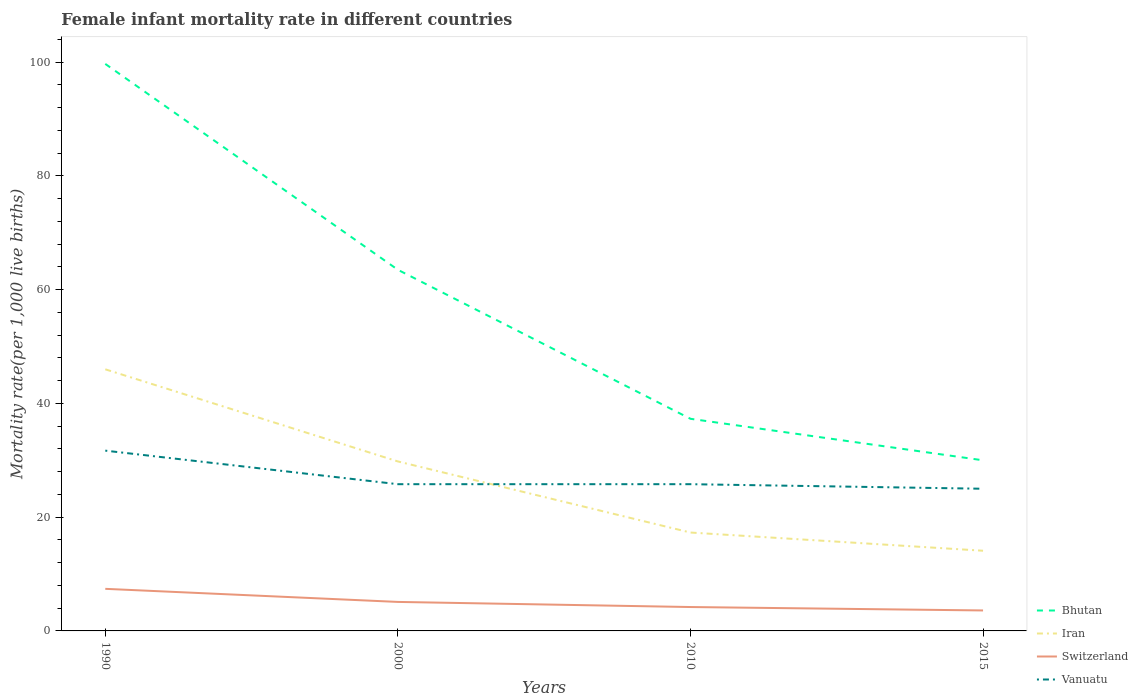In which year was the female infant mortality rate in Bhutan maximum?
Provide a succinct answer. 2015. What is the total female infant mortality rate in Bhutan in the graph?
Keep it short and to the point. 7.3. What is the difference between the highest and the second highest female infant mortality rate in Switzerland?
Provide a short and direct response. 3.8. How many lines are there?
Make the answer very short. 4. How many years are there in the graph?
Offer a terse response. 4. What is the difference between two consecutive major ticks on the Y-axis?
Make the answer very short. 20. Are the values on the major ticks of Y-axis written in scientific E-notation?
Keep it short and to the point. No. Does the graph contain any zero values?
Your response must be concise. No. Does the graph contain grids?
Your answer should be very brief. No. Where does the legend appear in the graph?
Make the answer very short. Bottom right. How many legend labels are there?
Your response must be concise. 4. What is the title of the graph?
Ensure brevity in your answer.  Female infant mortality rate in different countries. Does "Argentina" appear as one of the legend labels in the graph?
Make the answer very short. No. What is the label or title of the Y-axis?
Provide a succinct answer. Mortality rate(per 1,0 live births). What is the Mortality rate(per 1,000 live births) in Bhutan in 1990?
Keep it short and to the point. 99.7. What is the Mortality rate(per 1,000 live births) of Iran in 1990?
Provide a succinct answer. 46. What is the Mortality rate(per 1,000 live births) in Switzerland in 1990?
Provide a short and direct response. 7.4. What is the Mortality rate(per 1,000 live births) in Vanuatu in 1990?
Make the answer very short. 31.7. What is the Mortality rate(per 1,000 live births) in Bhutan in 2000?
Your response must be concise. 63.5. What is the Mortality rate(per 1,000 live births) of Iran in 2000?
Offer a very short reply. 29.8. What is the Mortality rate(per 1,000 live births) in Switzerland in 2000?
Your answer should be very brief. 5.1. What is the Mortality rate(per 1,000 live births) in Vanuatu in 2000?
Provide a succinct answer. 25.8. What is the Mortality rate(per 1,000 live births) in Bhutan in 2010?
Your answer should be very brief. 37.3. What is the Mortality rate(per 1,000 live births) in Iran in 2010?
Your answer should be very brief. 17.3. What is the Mortality rate(per 1,000 live births) of Switzerland in 2010?
Make the answer very short. 4.2. What is the Mortality rate(per 1,000 live births) in Vanuatu in 2010?
Provide a succinct answer. 25.8. What is the Mortality rate(per 1,000 live births) in Iran in 2015?
Offer a very short reply. 14.1. What is the Mortality rate(per 1,000 live births) in Vanuatu in 2015?
Keep it short and to the point. 25. Across all years, what is the maximum Mortality rate(per 1,000 live births) of Bhutan?
Ensure brevity in your answer.  99.7. Across all years, what is the maximum Mortality rate(per 1,000 live births) in Vanuatu?
Your answer should be very brief. 31.7. Across all years, what is the minimum Mortality rate(per 1,000 live births) in Iran?
Your answer should be compact. 14.1. Across all years, what is the minimum Mortality rate(per 1,000 live births) of Switzerland?
Your answer should be compact. 3.6. Across all years, what is the minimum Mortality rate(per 1,000 live births) of Vanuatu?
Provide a succinct answer. 25. What is the total Mortality rate(per 1,000 live births) in Bhutan in the graph?
Your answer should be compact. 230.5. What is the total Mortality rate(per 1,000 live births) in Iran in the graph?
Provide a succinct answer. 107.2. What is the total Mortality rate(per 1,000 live births) in Switzerland in the graph?
Give a very brief answer. 20.3. What is the total Mortality rate(per 1,000 live births) of Vanuatu in the graph?
Your answer should be very brief. 108.3. What is the difference between the Mortality rate(per 1,000 live births) of Bhutan in 1990 and that in 2000?
Your answer should be compact. 36.2. What is the difference between the Mortality rate(per 1,000 live births) of Iran in 1990 and that in 2000?
Your answer should be compact. 16.2. What is the difference between the Mortality rate(per 1,000 live births) in Switzerland in 1990 and that in 2000?
Make the answer very short. 2.3. What is the difference between the Mortality rate(per 1,000 live births) of Vanuatu in 1990 and that in 2000?
Offer a terse response. 5.9. What is the difference between the Mortality rate(per 1,000 live births) of Bhutan in 1990 and that in 2010?
Your response must be concise. 62.4. What is the difference between the Mortality rate(per 1,000 live births) in Iran in 1990 and that in 2010?
Offer a terse response. 28.7. What is the difference between the Mortality rate(per 1,000 live births) in Vanuatu in 1990 and that in 2010?
Your answer should be compact. 5.9. What is the difference between the Mortality rate(per 1,000 live births) in Bhutan in 1990 and that in 2015?
Offer a very short reply. 69.7. What is the difference between the Mortality rate(per 1,000 live births) in Iran in 1990 and that in 2015?
Give a very brief answer. 31.9. What is the difference between the Mortality rate(per 1,000 live births) of Switzerland in 1990 and that in 2015?
Provide a succinct answer. 3.8. What is the difference between the Mortality rate(per 1,000 live births) in Bhutan in 2000 and that in 2010?
Ensure brevity in your answer.  26.2. What is the difference between the Mortality rate(per 1,000 live births) in Switzerland in 2000 and that in 2010?
Offer a very short reply. 0.9. What is the difference between the Mortality rate(per 1,000 live births) of Bhutan in 2000 and that in 2015?
Offer a terse response. 33.5. What is the difference between the Mortality rate(per 1,000 live births) of Vanuatu in 2000 and that in 2015?
Your answer should be very brief. 0.8. What is the difference between the Mortality rate(per 1,000 live births) of Bhutan in 1990 and the Mortality rate(per 1,000 live births) of Iran in 2000?
Keep it short and to the point. 69.9. What is the difference between the Mortality rate(per 1,000 live births) of Bhutan in 1990 and the Mortality rate(per 1,000 live births) of Switzerland in 2000?
Offer a very short reply. 94.6. What is the difference between the Mortality rate(per 1,000 live births) of Bhutan in 1990 and the Mortality rate(per 1,000 live births) of Vanuatu in 2000?
Keep it short and to the point. 73.9. What is the difference between the Mortality rate(per 1,000 live births) in Iran in 1990 and the Mortality rate(per 1,000 live births) in Switzerland in 2000?
Make the answer very short. 40.9. What is the difference between the Mortality rate(per 1,000 live births) in Iran in 1990 and the Mortality rate(per 1,000 live births) in Vanuatu in 2000?
Provide a short and direct response. 20.2. What is the difference between the Mortality rate(per 1,000 live births) of Switzerland in 1990 and the Mortality rate(per 1,000 live births) of Vanuatu in 2000?
Provide a short and direct response. -18.4. What is the difference between the Mortality rate(per 1,000 live births) of Bhutan in 1990 and the Mortality rate(per 1,000 live births) of Iran in 2010?
Offer a terse response. 82.4. What is the difference between the Mortality rate(per 1,000 live births) in Bhutan in 1990 and the Mortality rate(per 1,000 live births) in Switzerland in 2010?
Keep it short and to the point. 95.5. What is the difference between the Mortality rate(per 1,000 live births) in Bhutan in 1990 and the Mortality rate(per 1,000 live births) in Vanuatu in 2010?
Your response must be concise. 73.9. What is the difference between the Mortality rate(per 1,000 live births) of Iran in 1990 and the Mortality rate(per 1,000 live births) of Switzerland in 2010?
Your response must be concise. 41.8. What is the difference between the Mortality rate(per 1,000 live births) of Iran in 1990 and the Mortality rate(per 1,000 live births) of Vanuatu in 2010?
Offer a terse response. 20.2. What is the difference between the Mortality rate(per 1,000 live births) of Switzerland in 1990 and the Mortality rate(per 1,000 live births) of Vanuatu in 2010?
Make the answer very short. -18.4. What is the difference between the Mortality rate(per 1,000 live births) in Bhutan in 1990 and the Mortality rate(per 1,000 live births) in Iran in 2015?
Your answer should be compact. 85.6. What is the difference between the Mortality rate(per 1,000 live births) of Bhutan in 1990 and the Mortality rate(per 1,000 live births) of Switzerland in 2015?
Provide a succinct answer. 96.1. What is the difference between the Mortality rate(per 1,000 live births) in Bhutan in 1990 and the Mortality rate(per 1,000 live births) in Vanuatu in 2015?
Offer a terse response. 74.7. What is the difference between the Mortality rate(per 1,000 live births) in Iran in 1990 and the Mortality rate(per 1,000 live births) in Switzerland in 2015?
Provide a short and direct response. 42.4. What is the difference between the Mortality rate(per 1,000 live births) in Iran in 1990 and the Mortality rate(per 1,000 live births) in Vanuatu in 2015?
Make the answer very short. 21. What is the difference between the Mortality rate(per 1,000 live births) in Switzerland in 1990 and the Mortality rate(per 1,000 live births) in Vanuatu in 2015?
Offer a terse response. -17.6. What is the difference between the Mortality rate(per 1,000 live births) in Bhutan in 2000 and the Mortality rate(per 1,000 live births) in Iran in 2010?
Your answer should be compact. 46.2. What is the difference between the Mortality rate(per 1,000 live births) of Bhutan in 2000 and the Mortality rate(per 1,000 live births) of Switzerland in 2010?
Your response must be concise. 59.3. What is the difference between the Mortality rate(per 1,000 live births) of Bhutan in 2000 and the Mortality rate(per 1,000 live births) of Vanuatu in 2010?
Give a very brief answer. 37.7. What is the difference between the Mortality rate(per 1,000 live births) of Iran in 2000 and the Mortality rate(per 1,000 live births) of Switzerland in 2010?
Offer a very short reply. 25.6. What is the difference between the Mortality rate(per 1,000 live births) of Iran in 2000 and the Mortality rate(per 1,000 live births) of Vanuatu in 2010?
Offer a terse response. 4. What is the difference between the Mortality rate(per 1,000 live births) in Switzerland in 2000 and the Mortality rate(per 1,000 live births) in Vanuatu in 2010?
Your response must be concise. -20.7. What is the difference between the Mortality rate(per 1,000 live births) of Bhutan in 2000 and the Mortality rate(per 1,000 live births) of Iran in 2015?
Your answer should be very brief. 49.4. What is the difference between the Mortality rate(per 1,000 live births) in Bhutan in 2000 and the Mortality rate(per 1,000 live births) in Switzerland in 2015?
Your answer should be very brief. 59.9. What is the difference between the Mortality rate(per 1,000 live births) of Bhutan in 2000 and the Mortality rate(per 1,000 live births) of Vanuatu in 2015?
Offer a very short reply. 38.5. What is the difference between the Mortality rate(per 1,000 live births) of Iran in 2000 and the Mortality rate(per 1,000 live births) of Switzerland in 2015?
Keep it short and to the point. 26.2. What is the difference between the Mortality rate(per 1,000 live births) in Iran in 2000 and the Mortality rate(per 1,000 live births) in Vanuatu in 2015?
Your answer should be very brief. 4.8. What is the difference between the Mortality rate(per 1,000 live births) of Switzerland in 2000 and the Mortality rate(per 1,000 live births) of Vanuatu in 2015?
Provide a succinct answer. -19.9. What is the difference between the Mortality rate(per 1,000 live births) in Bhutan in 2010 and the Mortality rate(per 1,000 live births) in Iran in 2015?
Provide a short and direct response. 23.2. What is the difference between the Mortality rate(per 1,000 live births) in Bhutan in 2010 and the Mortality rate(per 1,000 live births) in Switzerland in 2015?
Your answer should be very brief. 33.7. What is the difference between the Mortality rate(per 1,000 live births) of Iran in 2010 and the Mortality rate(per 1,000 live births) of Switzerland in 2015?
Your response must be concise. 13.7. What is the difference between the Mortality rate(per 1,000 live births) of Switzerland in 2010 and the Mortality rate(per 1,000 live births) of Vanuatu in 2015?
Provide a short and direct response. -20.8. What is the average Mortality rate(per 1,000 live births) in Bhutan per year?
Keep it short and to the point. 57.62. What is the average Mortality rate(per 1,000 live births) of Iran per year?
Your answer should be compact. 26.8. What is the average Mortality rate(per 1,000 live births) of Switzerland per year?
Provide a succinct answer. 5.08. What is the average Mortality rate(per 1,000 live births) in Vanuatu per year?
Your answer should be compact. 27.07. In the year 1990, what is the difference between the Mortality rate(per 1,000 live births) of Bhutan and Mortality rate(per 1,000 live births) of Iran?
Your answer should be compact. 53.7. In the year 1990, what is the difference between the Mortality rate(per 1,000 live births) of Bhutan and Mortality rate(per 1,000 live births) of Switzerland?
Keep it short and to the point. 92.3. In the year 1990, what is the difference between the Mortality rate(per 1,000 live births) of Bhutan and Mortality rate(per 1,000 live births) of Vanuatu?
Give a very brief answer. 68. In the year 1990, what is the difference between the Mortality rate(per 1,000 live births) of Iran and Mortality rate(per 1,000 live births) of Switzerland?
Your answer should be very brief. 38.6. In the year 1990, what is the difference between the Mortality rate(per 1,000 live births) in Iran and Mortality rate(per 1,000 live births) in Vanuatu?
Give a very brief answer. 14.3. In the year 1990, what is the difference between the Mortality rate(per 1,000 live births) in Switzerland and Mortality rate(per 1,000 live births) in Vanuatu?
Provide a succinct answer. -24.3. In the year 2000, what is the difference between the Mortality rate(per 1,000 live births) of Bhutan and Mortality rate(per 1,000 live births) of Iran?
Make the answer very short. 33.7. In the year 2000, what is the difference between the Mortality rate(per 1,000 live births) of Bhutan and Mortality rate(per 1,000 live births) of Switzerland?
Keep it short and to the point. 58.4. In the year 2000, what is the difference between the Mortality rate(per 1,000 live births) of Bhutan and Mortality rate(per 1,000 live births) of Vanuatu?
Keep it short and to the point. 37.7. In the year 2000, what is the difference between the Mortality rate(per 1,000 live births) in Iran and Mortality rate(per 1,000 live births) in Switzerland?
Your answer should be very brief. 24.7. In the year 2000, what is the difference between the Mortality rate(per 1,000 live births) of Iran and Mortality rate(per 1,000 live births) of Vanuatu?
Provide a short and direct response. 4. In the year 2000, what is the difference between the Mortality rate(per 1,000 live births) of Switzerland and Mortality rate(per 1,000 live births) of Vanuatu?
Keep it short and to the point. -20.7. In the year 2010, what is the difference between the Mortality rate(per 1,000 live births) in Bhutan and Mortality rate(per 1,000 live births) in Iran?
Provide a short and direct response. 20. In the year 2010, what is the difference between the Mortality rate(per 1,000 live births) of Bhutan and Mortality rate(per 1,000 live births) of Switzerland?
Provide a succinct answer. 33.1. In the year 2010, what is the difference between the Mortality rate(per 1,000 live births) in Bhutan and Mortality rate(per 1,000 live births) in Vanuatu?
Your response must be concise. 11.5. In the year 2010, what is the difference between the Mortality rate(per 1,000 live births) in Iran and Mortality rate(per 1,000 live births) in Vanuatu?
Give a very brief answer. -8.5. In the year 2010, what is the difference between the Mortality rate(per 1,000 live births) in Switzerland and Mortality rate(per 1,000 live births) in Vanuatu?
Your answer should be compact. -21.6. In the year 2015, what is the difference between the Mortality rate(per 1,000 live births) in Bhutan and Mortality rate(per 1,000 live births) in Iran?
Offer a terse response. 15.9. In the year 2015, what is the difference between the Mortality rate(per 1,000 live births) in Bhutan and Mortality rate(per 1,000 live births) in Switzerland?
Your answer should be compact. 26.4. In the year 2015, what is the difference between the Mortality rate(per 1,000 live births) of Switzerland and Mortality rate(per 1,000 live births) of Vanuatu?
Your answer should be very brief. -21.4. What is the ratio of the Mortality rate(per 1,000 live births) of Bhutan in 1990 to that in 2000?
Ensure brevity in your answer.  1.57. What is the ratio of the Mortality rate(per 1,000 live births) of Iran in 1990 to that in 2000?
Your answer should be very brief. 1.54. What is the ratio of the Mortality rate(per 1,000 live births) of Switzerland in 1990 to that in 2000?
Make the answer very short. 1.45. What is the ratio of the Mortality rate(per 1,000 live births) in Vanuatu in 1990 to that in 2000?
Make the answer very short. 1.23. What is the ratio of the Mortality rate(per 1,000 live births) of Bhutan in 1990 to that in 2010?
Your answer should be very brief. 2.67. What is the ratio of the Mortality rate(per 1,000 live births) in Iran in 1990 to that in 2010?
Your response must be concise. 2.66. What is the ratio of the Mortality rate(per 1,000 live births) in Switzerland in 1990 to that in 2010?
Give a very brief answer. 1.76. What is the ratio of the Mortality rate(per 1,000 live births) of Vanuatu in 1990 to that in 2010?
Offer a terse response. 1.23. What is the ratio of the Mortality rate(per 1,000 live births) in Bhutan in 1990 to that in 2015?
Offer a terse response. 3.32. What is the ratio of the Mortality rate(per 1,000 live births) in Iran in 1990 to that in 2015?
Provide a succinct answer. 3.26. What is the ratio of the Mortality rate(per 1,000 live births) in Switzerland in 1990 to that in 2015?
Make the answer very short. 2.06. What is the ratio of the Mortality rate(per 1,000 live births) in Vanuatu in 1990 to that in 2015?
Keep it short and to the point. 1.27. What is the ratio of the Mortality rate(per 1,000 live births) in Bhutan in 2000 to that in 2010?
Ensure brevity in your answer.  1.7. What is the ratio of the Mortality rate(per 1,000 live births) in Iran in 2000 to that in 2010?
Give a very brief answer. 1.72. What is the ratio of the Mortality rate(per 1,000 live births) of Switzerland in 2000 to that in 2010?
Provide a succinct answer. 1.21. What is the ratio of the Mortality rate(per 1,000 live births) in Bhutan in 2000 to that in 2015?
Make the answer very short. 2.12. What is the ratio of the Mortality rate(per 1,000 live births) of Iran in 2000 to that in 2015?
Your answer should be compact. 2.11. What is the ratio of the Mortality rate(per 1,000 live births) in Switzerland in 2000 to that in 2015?
Ensure brevity in your answer.  1.42. What is the ratio of the Mortality rate(per 1,000 live births) in Vanuatu in 2000 to that in 2015?
Your answer should be compact. 1.03. What is the ratio of the Mortality rate(per 1,000 live births) of Bhutan in 2010 to that in 2015?
Give a very brief answer. 1.24. What is the ratio of the Mortality rate(per 1,000 live births) of Iran in 2010 to that in 2015?
Provide a short and direct response. 1.23. What is the ratio of the Mortality rate(per 1,000 live births) in Switzerland in 2010 to that in 2015?
Offer a very short reply. 1.17. What is the ratio of the Mortality rate(per 1,000 live births) in Vanuatu in 2010 to that in 2015?
Offer a terse response. 1.03. What is the difference between the highest and the second highest Mortality rate(per 1,000 live births) of Bhutan?
Ensure brevity in your answer.  36.2. What is the difference between the highest and the lowest Mortality rate(per 1,000 live births) in Bhutan?
Your answer should be very brief. 69.7. What is the difference between the highest and the lowest Mortality rate(per 1,000 live births) of Iran?
Ensure brevity in your answer.  31.9. What is the difference between the highest and the lowest Mortality rate(per 1,000 live births) in Switzerland?
Your response must be concise. 3.8. What is the difference between the highest and the lowest Mortality rate(per 1,000 live births) in Vanuatu?
Give a very brief answer. 6.7. 